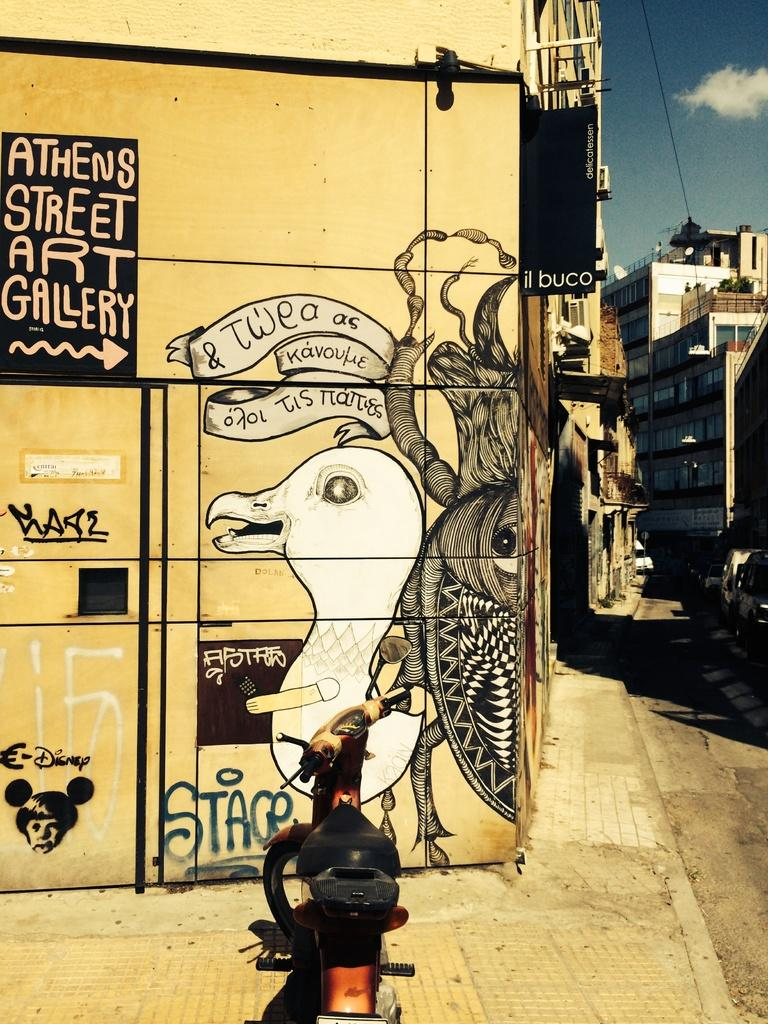Provide a one-sentence caption for the provided image. A yellow building has a picture of a dove and an arrow pointing to Athens Street Art Gallery. 